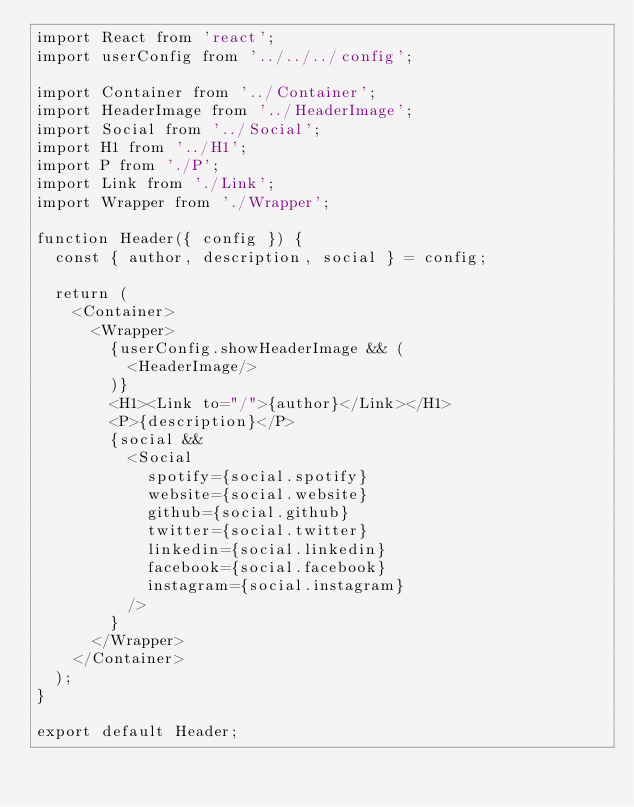<code> <loc_0><loc_0><loc_500><loc_500><_JavaScript_>import React from 'react';
import userConfig from '../../../config';

import Container from '../Container';
import HeaderImage from '../HeaderImage';
import Social from '../Social';
import H1 from '../H1';
import P from './P';
import Link from './Link';
import Wrapper from './Wrapper';

function Header({ config }) {
  const { author, description, social } = config;

  return (
    <Container>
      <Wrapper>
        {userConfig.showHeaderImage && (
          <HeaderImage/>
        )}
        <H1><Link to="/">{author}</Link></H1>
        <P>{description}</P>
        {social &&
          <Social
            spotify={social.spotify}
            website={social.website}
            github={social.github}
            twitter={social.twitter}
            linkedin={social.linkedin}
            facebook={social.facebook}
            instagram={social.instagram}
          />
        }
      </Wrapper>
    </Container> 
  );
}

export default Header;
</code> 